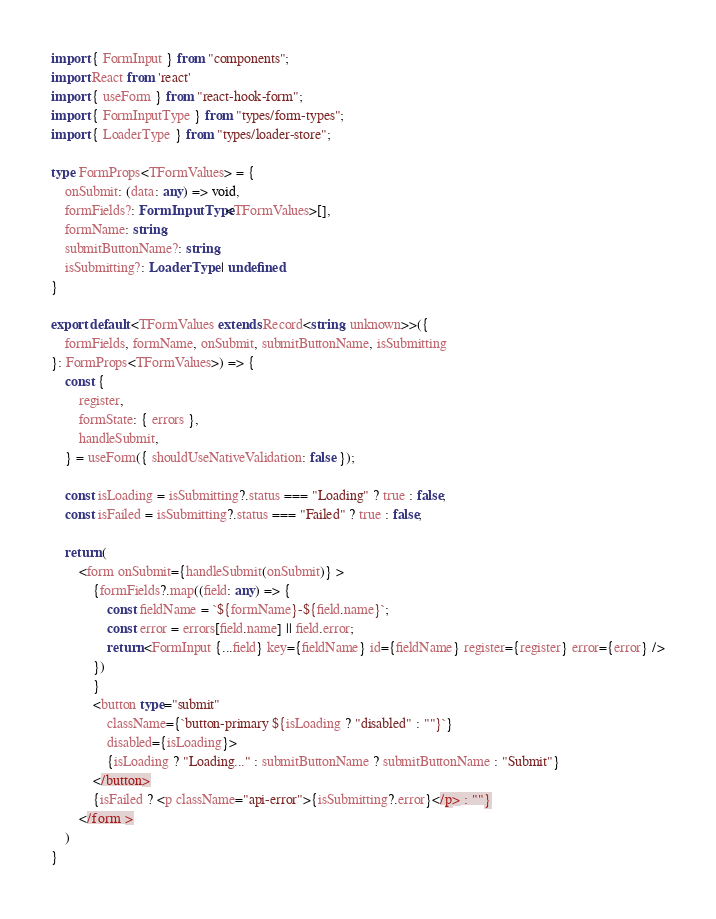Convert code to text. <code><loc_0><loc_0><loc_500><loc_500><_TypeScript_>import { FormInput } from "components";
import React from 'react'
import { useForm } from "react-hook-form";
import { FormInputType } from "types/form-types";
import { LoaderType } from "types/loader-store";

type FormProps<TFormValues> = {
    onSubmit: (data: any) => void,
    formFields?: FormInputType<TFormValues>[],
    formName: string,
    submitButtonName?: string,
    isSubmitting?: LoaderType | undefined
}

export default <TFormValues extends Record<string, unknown>>({
    formFields, formName, onSubmit, submitButtonName, isSubmitting
}: FormProps<TFormValues>) => {
    const {
        register,
        formState: { errors },
        handleSubmit,
    } = useForm({ shouldUseNativeValidation: false });

    const isLoading = isSubmitting?.status === "Loading" ? true : false;
    const isFailed = isSubmitting?.status === "Failed" ? true : false;

    return (
        <form onSubmit={handleSubmit(onSubmit)} >
            {formFields?.map((field: any) => {
                const fieldName = `${formName}-${field.name}`;
                const error = errors[field.name] || field.error;
                return <FormInput {...field} key={fieldName} id={fieldName} register={register} error={error} />
            })
            }
            <button type="submit"
                className={`button-primary ${isLoading ? "disabled" : ""}`}
                disabled={isLoading}>
                {isLoading ? "Loading..." : submitButtonName ? submitButtonName : "Submit"}
            </button>
            {isFailed ? <p className="api-error">{isSubmitting?.error}</p> : ""}
        </form >
    )
}</code> 